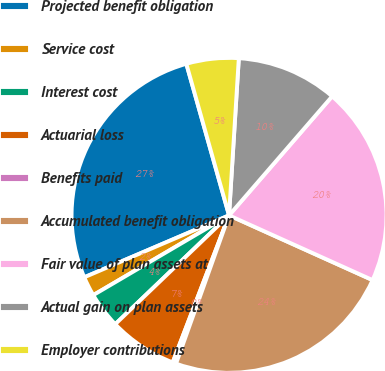<chart> <loc_0><loc_0><loc_500><loc_500><pie_chart><fcel>Projected benefit obligation<fcel>Service cost<fcel>Interest cost<fcel>Actuarial loss<fcel>Benefits paid<fcel>Accumulated benefit obligation<fcel>Fair value of plan assets at<fcel>Actual gain on plan assets<fcel>Employer contributions<nl><fcel>27.06%<fcel>2.02%<fcel>3.69%<fcel>7.03%<fcel>0.36%<fcel>23.72%<fcel>20.38%<fcel>10.37%<fcel>5.36%<nl></chart> 